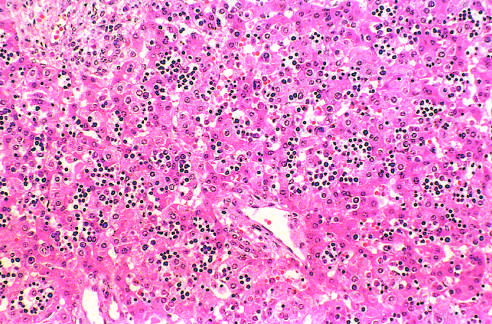what are numerous islands of extramedullary hematopoiesis scattered among in this histologic preparation from an infant with nonimmune hydrops fetalis?
Answer the question using a single word or phrase. Mature hepatocytes 